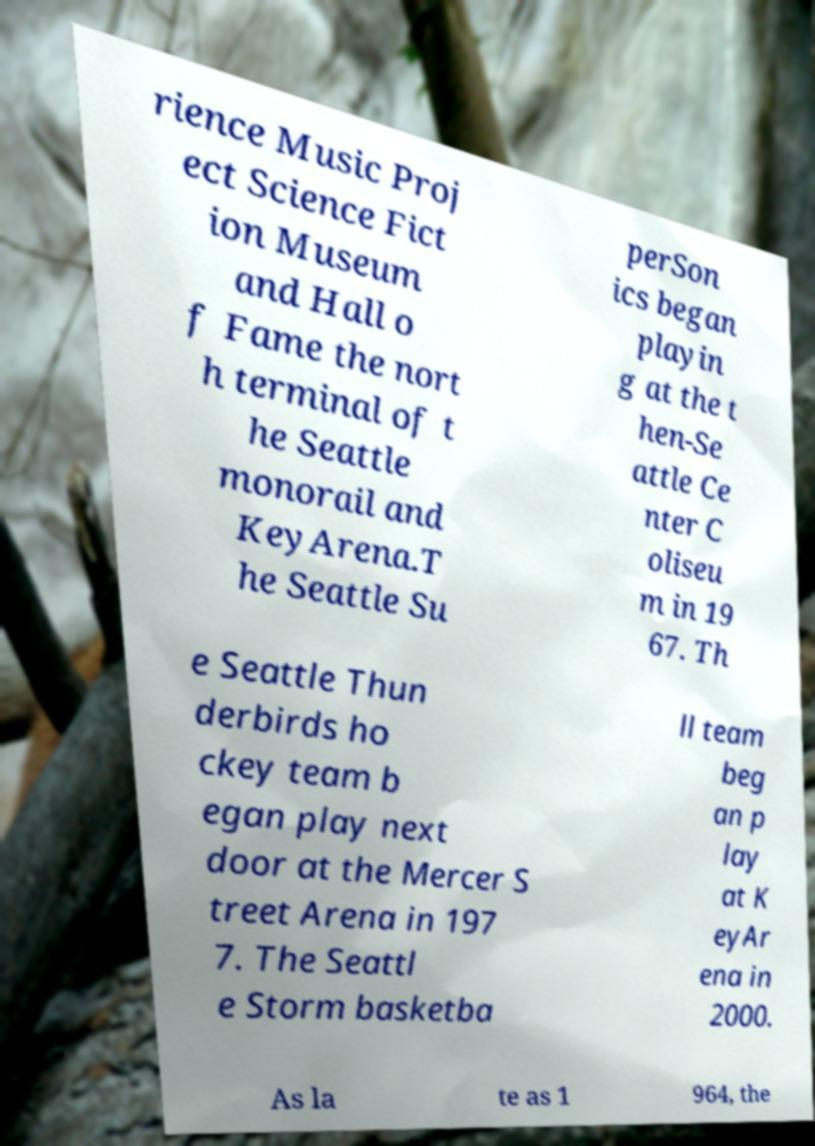Can you read and provide the text displayed in the image?This photo seems to have some interesting text. Can you extract and type it out for me? rience Music Proj ect Science Fict ion Museum and Hall o f Fame the nort h terminal of t he Seattle monorail and KeyArena.T he Seattle Su perSon ics began playin g at the t hen-Se attle Ce nter C oliseu m in 19 67. Th e Seattle Thun derbirds ho ckey team b egan play next door at the Mercer S treet Arena in 197 7. The Seattl e Storm basketba ll team beg an p lay at K eyAr ena in 2000. As la te as 1 964, the 